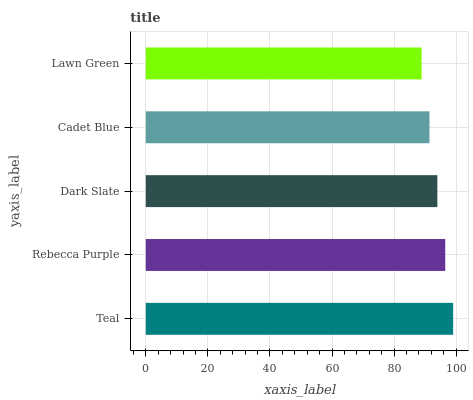Is Lawn Green the minimum?
Answer yes or no. Yes. Is Teal the maximum?
Answer yes or no. Yes. Is Rebecca Purple the minimum?
Answer yes or no. No. Is Rebecca Purple the maximum?
Answer yes or no. No. Is Teal greater than Rebecca Purple?
Answer yes or no. Yes. Is Rebecca Purple less than Teal?
Answer yes or no. Yes. Is Rebecca Purple greater than Teal?
Answer yes or no. No. Is Teal less than Rebecca Purple?
Answer yes or no. No. Is Dark Slate the high median?
Answer yes or no. Yes. Is Dark Slate the low median?
Answer yes or no. Yes. Is Lawn Green the high median?
Answer yes or no. No. Is Rebecca Purple the low median?
Answer yes or no. No. 